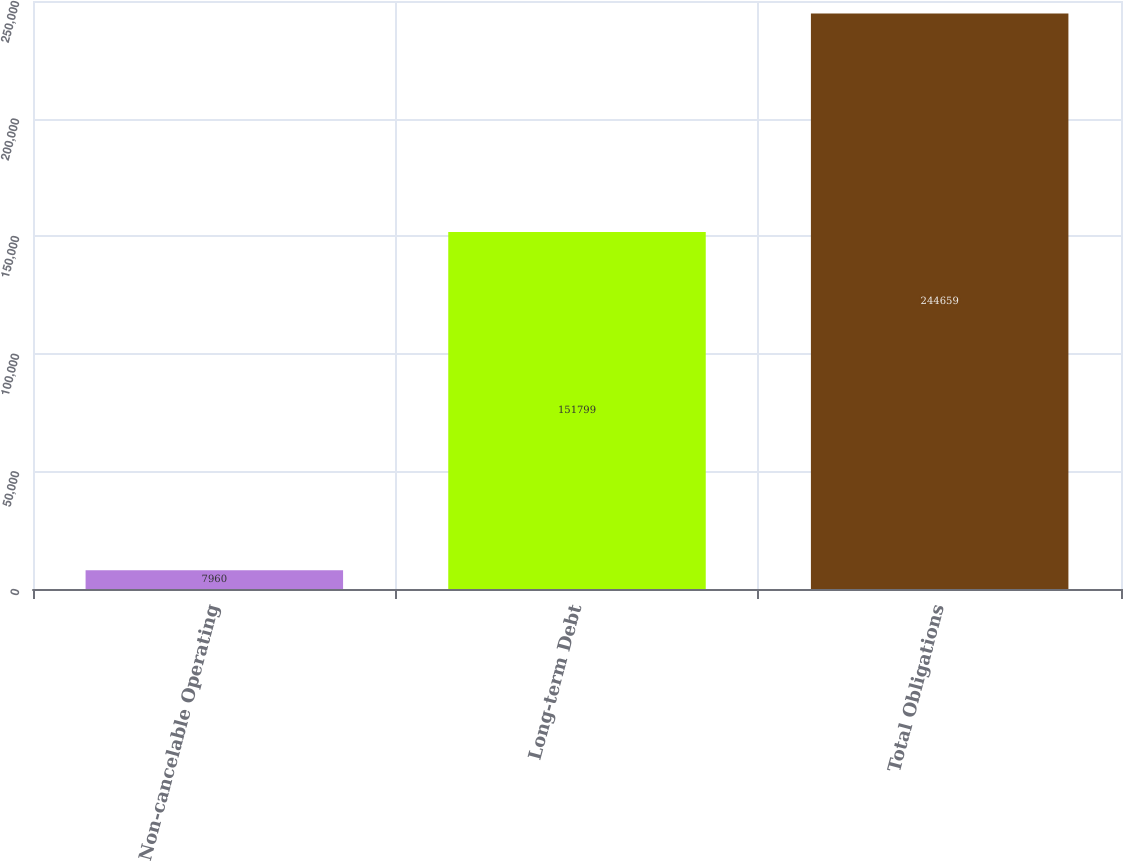Convert chart. <chart><loc_0><loc_0><loc_500><loc_500><bar_chart><fcel>Non-cancelable Operating<fcel>Long-term Debt<fcel>Total Obligations<nl><fcel>7960<fcel>151799<fcel>244659<nl></chart> 